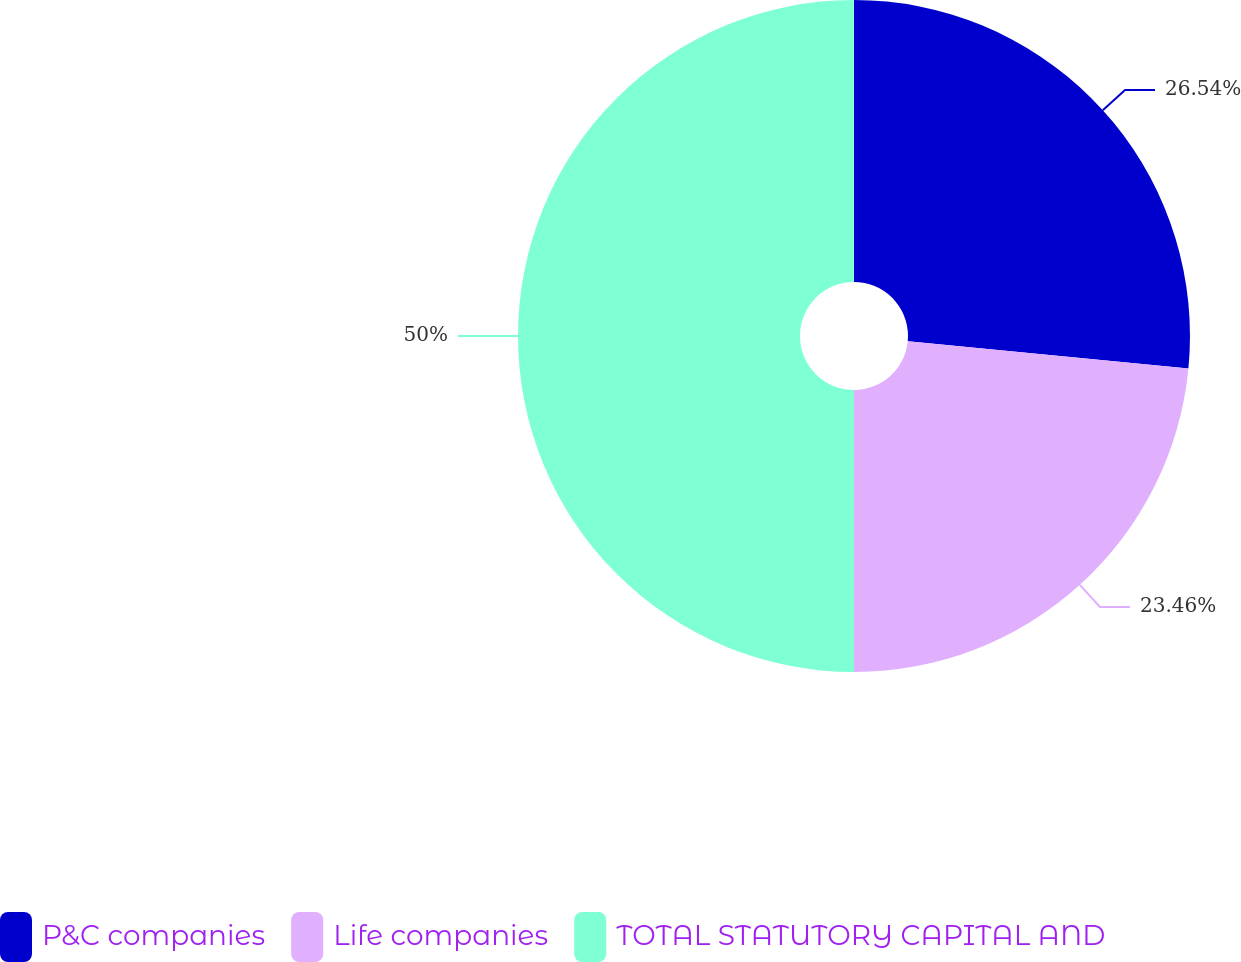Convert chart. <chart><loc_0><loc_0><loc_500><loc_500><pie_chart><fcel>P&C companies<fcel>Life companies<fcel>TOTAL STATUTORY CAPITAL AND<nl><fcel>26.54%<fcel>23.46%<fcel>50.0%<nl></chart> 